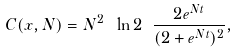Convert formula to latex. <formula><loc_0><loc_0><loc_500><loc_500>C ( x , N ) = N ^ { 2 } \ \ln 2 \ \frac { 2 e ^ { N t } } { ( 2 + e ^ { N t } ) ^ { 2 } } ,</formula> 